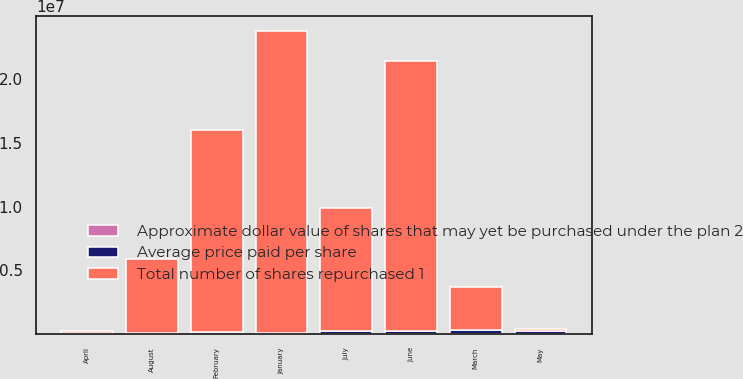Convert chart. <chart><loc_0><loc_0><loc_500><loc_500><stacked_bar_chart><ecel><fcel>January<fcel>February<fcel>March<fcel>April<fcel>May<fcel>June<fcel>July<fcel>August<nl><fcel>Average price paid per share<fcel>94818<fcel>188199<fcel>295463<fcel>109670<fcel>271395<fcel>265103<fcel>213925<fcel>68536<nl><fcel>Approximate dollar value of shares that may yet be purchased under the plan 2<fcel>41.44<fcel>41.56<fcel>42.22<fcel>46.06<fcel>49.32<fcel>52.03<fcel>53.38<fcel>56.44<nl><fcel>Total number of shares repurchased 1<fcel>2.36609e+07<fcel>1.58387e+07<fcel>3.36352e+06<fcel>148934<fcel>148934<fcel>2.11328e+07<fcel>9.71437e+06<fcel>5.8462e+06<nl></chart> 